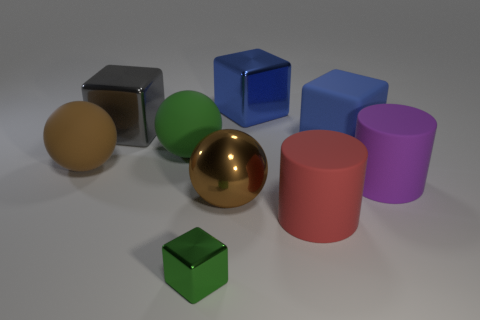Do the brown object that is to the right of the big green matte thing and the large blue matte thing have the same shape?
Ensure brevity in your answer.  No. There is a brown object that is left of the green object that is on the left side of the thing in front of the red matte object; what is its size?
Provide a short and direct response. Large. What is the size of the matte ball that is the same color as the large shiny sphere?
Give a very brief answer. Large. What number of things are tiny red rubber spheres or blue shiny blocks?
Keep it short and to the point. 1. The matte thing that is left of the large brown metal object and to the right of the large brown matte thing has what shape?
Give a very brief answer. Sphere. Is the shape of the gray metallic thing the same as the purple matte thing to the right of the large gray shiny block?
Keep it short and to the point. No. Are there any blue cubes to the left of the large brown metal object?
Provide a succinct answer. No. What material is the other thing that is the same color as the tiny thing?
Your answer should be very brief. Rubber. How many cubes are either tiny metallic things or big cyan objects?
Offer a terse response. 1. Do the gray metal object and the large brown matte object have the same shape?
Give a very brief answer. No. 